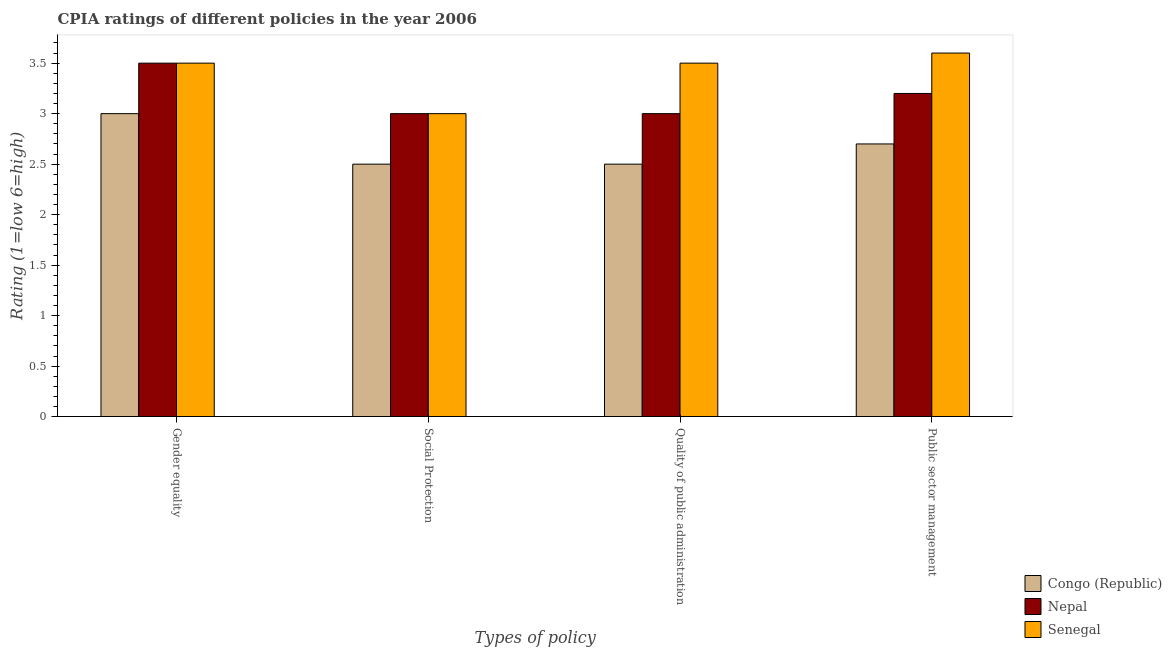How many different coloured bars are there?
Make the answer very short. 3. How many groups of bars are there?
Your response must be concise. 4. Are the number of bars per tick equal to the number of legend labels?
Make the answer very short. Yes. How many bars are there on the 4th tick from the left?
Your response must be concise. 3. What is the label of the 1st group of bars from the left?
Offer a terse response. Gender equality. Across all countries, what is the maximum cpia rating of quality of public administration?
Provide a succinct answer. 3.5. Across all countries, what is the minimum cpia rating of quality of public administration?
Your answer should be very brief. 2.5. In which country was the cpia rating of social protection maximum?
Keep it short and to the point. Nepal. In which country was the cpia rating of gender equality minimum?
Your response must be concise. Congo (Republic). What is the total cpia rating of quality of public administration in the graph?
Your answer should be compact. 9. What is the difference between the cpia rating of quality of public administration in Nepal and that in Congo (Republic)?
Give a very brief answer. 0.5. What is the average cpia rating of gender equality per country?
Give a very brief answer. 3.33. What is the difference between the cpia rating of public sector management and cpia rating of gender equality in Nepal?
Offer a terse response. -0.3. In how many countries, is the cpia rating of gender equality greater than 2.4 ?
Make the answer very short. 3. Is the cpia rating of public sector management in Senegal less than that in Nepal?
Your response must be concise. No. What is the difference between the highest and the second highest cpia rating of public sector management?
Provide a succinct answer. 0.4. Is it the case that in every country, the sum of the cpia rating of social protection and cpia rating of gender equality is greater than the sum of cpia rating of quality of public administration and cpia rating of public sector management?
Provide a succinct answer. No. What does the 2nd bar from the left in Public sector management represents?
Provide a succinct answer. Nepal. What does the 2nd bar from the right in Public sector management represents?
Provide a succinct answer. Nepal. Is it the case that in every country, the sum of the cpia rating of gender equality and cpia rating of social protection is greater than the cpia rating of quality of public administration?
Provide a succinct answer. Yes. How many bars are there?
Make the answer very short. 12. What is the difference between two consecutive major ticks on the Y-axis?
Give a very brief answer. 0.5. Are the values on the major ticks of Y-axis written in scientific E-notation?
Provide a short and direct response. No. Does the graph contain any zero values?
Your response must be concise. No. Does the graph contain grids?
Keep it short and to the point. No. How are the legend labels stacked?
Offer a terse response. Vertical. What is the title of the graph?
Offer a very short reply. CPIA ratings of different policies in the year 2006. What is the label or title of the X-axis?
Make the answer very short. Types of policy. What is the label or title of the Y-axis?
Your answer should be very brief. Rating (1=low 6=high). What is the Rating (1=low 6=high) in Congo (Republic) in Gender equality?
Your answer should be very brief. 3. What is the Rating (1=low 6=high) in Nepal in Gender equality?
Keep it short and to the point. 3.5. What is the Rating (1=low 6=high) of Senegal in Gender equality?
Your response must be concise. 3.5. What is the Rating (1=low 6=high) of Senegal in Social Protection?
Your response must be concise. 3. What is the Rating (1=low 6=high) of Congo (Republic) in Quality of public administration?
Provide a short and direct response. 2.5. What is the Rating (1=low 6=high) in Senegal in Quality of public administration?
Offer a terse response. 3.5. What is the Rating (1=low 6=high) in Congo (Republic) in Public sector management?
Your answer should be very brief. 2.7. What is the Rating (1=low 6=high) in Nepal in Public sector management?
Offer a terse response. 3.2. What is the Rating (1=low 6=high) in Senegal in Public sector management?
Give a very brief answer. 3.6. Across all Types of policy, what is the maximum Rating (1=low 6=high) in Senegal?
Keep it short and to the point. 3.6. Across all Types of policy, what is the minimum Rating (1=low 6=high) in Congo (Republic)?
Provide a succinct answer. 2.5. What is the difference between the Rating (1=low 6=high) of Congo (Republic) in Gender equality and that in Social Protection?
Your answer should be very brief. 0.5. What is the difference between the Rating (1=low 6=high) in Congo (Republic) in Gender equality and that in Quality of public administration?
Ensure brevity in your answer.  0.5. What is the difference between the Rating (1=low 6=high) of Nepal in Gender equality and that in Quality of public administration?
Provide a succinct answer. 0.5. What is the difference between the Rating (1=low 6=high) in Congo (Republic) in Gender equality and that in Public sector management?
Ensure brevity in your answer.  0.3. What is the difference between the Rating (1=low 6=high) of Senegal in Gender equality and that in Public sector management?
Your response must be concise. -0.1. What is the difference between the Rating (1=low 6=high) of Senegal in Social Protection and that in Quality of public administration?
Provide a short and direct response. -0.5. What is the difference between the Rating (1=low 6=high) in Nepal in Social Protection and that in Public sector management?
Keep it short and to the point. -0.2. What is the difference between the Rating (1=low 6=high) in Nepal in Quality of public administration and that in Public sector management?
Your answer should be very brief. -0.2. What is the difference between the Rating (1=low 6=high) in Congo (Republic) in Gender equality and the Rating (1=low 6=high) in Nepal in Social Protection?
Keep it short and to the point. 0. What is the difference between the Rating (1=low 6=high) in Congo (Republic) in Gender equality and the Rating (1=low 6=high) in Senegal in Quality of public administration?
Offer a terse response. -0.5. What is the difference between the Rating (1=low 6=high) of Nepal in Gender equality and the Rating (1=low 6=high) of Senegal in Quality of public administration?
Give a very brief answer. 0. What is the difference between the Rating (1=low 6=high) of Congo (Republic) in Gender equality and the Rating (1=low 6=high) of Nepal in Public sector management?
Offer a very short reply. -0.2. What is the difference between the Rating (1=low 6=high) of Congo (Republic) in Gender equality and the Rating (1=low 6=high) of Senegal in Public sector management?
Give a very brief answer. -0.6. What is the difference between the Rating (1=low 6=high) of Congo (Republic) in Social Protection and the Rating (1=low 6=high) of Nepal in Quality of public administration?
Keep it short and to the point. -0.5. What is the difference between the Rating (1=low 6=high) in Congo (Republic) in Social Protection and the Rating (1=low 6=high) in Senegal in Quality of public administration?
Provide a succinct answer. -1. What is the difference between the Rating (1=low 6=high) in Congo (Republic) in Social Protection and the Rating (1=low 6=high) in Nepal in Public sector management?
Offer a terse response. -0.7. What is the difference between the Rating (1=low 6=high) in Nepal in Social Protection and the Rating (1=low 6=high) in Senegal in Public sector management?
Give a very brief answer. -0.6. What is the difference between the Rating (1=low 6=high) of Congo (Republic) in Quality of public administration and the Rating (1=low 6=high) of Nepal in Public sector management?
Your answer should be compact. -0.7. What is the difference between the Rating (1=low 6=high) of Congo (Republic) in Quality of public administration and the Rating (1=low 6=high) of Senegal in Public sector management?
Make the answer very short. -1.1. What is the average Rating (1=low 6=high) of Congo (Republic) per Types of policy?
Your response must be concise. 2.67. What is the average Rating (1=low 6=high) of Nepal per Types of policy?
Offer a very short reply. 3.17. What is the average Rating (1=low 6=high) of Senegal per Types of policy?
Your response must be concise. 3.4. What is the difference between the Rating (1=low 6=high) in Congo (Republic) and Rating (1=low 6=high) in Nepal in Gender equality?
Ensure brevity in your answer.  -0.5. What is the difference between the Rating (1=low 6=high) of Congo (Republic) and Rating (1=low 6=high) of Nepal in Social Protection?
Give a very brief answer. -0.5. What is the difference between the Rating (1=low 6=high) of Congo (Republic) and Rating (1=low 6=high) of Nepal in Quality of public administration?
Offer a very short reply. -0.5. What is the difference between the Rating (1=low 6=high) in Nepal and Rating (1=low 6=high) in Senegal in Quality of public administration?
Provide a short and direct response. -0.5. What is the difference between the Rating (1=low 6=high) of Congo (Republic) and Rating (1=low 6=high) of Nepal in Public sector management?
Provide a succinct answer. -0.5. What is the difference between the Rating (1=low 6=high) of Nepal and Rating (1=low 6=high) of Senegal in Public sector management?
Offer a terse response. -0.4. What is the ratio of the Rating (1=low 6=high) in Congo (Republic) in Gender equality to that in Social Protection?
Keep it short and to the point. 1.2. What is the ratio of the Rating (1=low 6=high) in Senegal in Gender equality to that in Social Protection?
Provide a short and direct response. 1.17. What is the ratio of the Rating (1=low 6=high) of Senegal in Gender equality to that in Quality of public administration?
Ensure brevity in your answer.  1. What is the ratio of the Rating (1=low 6=high) in Congo (Republic) in Gender equality to that in Public sector management?
Ensure brevity in your answer.  1.11. What is the ratio of the Rating (1=low 6=high) of Nepal in Gender equality to that in Public sector management?
Make the answer very short. 1.09. What is the ratio of the Rating (1=low 6=high) in Senegal in Gender equality to that in Public sector management?
Your response must be concise. 0.97. What is the ratio of the Rating (1=low 6=high) in Congo (Republic) in Social Protection to that in Quality of public administration?
Your answer should be very brief. 1. What is the ratio of the Rating (1=low 6=high) of Nepal in Social Protection to that in Quality of public administration?
Make the answer very short. 1. What is the ratio of the Rating (1=low 6=high) in Senegal in Social Protection to that in Quality of public administration?
Ensure brevity in your answer.  0.86. What is the ratio of the Rating (1=low 6=high) of Congo (Republic) in Social Protection to that in Public sector management?
Your answer should be compact. 0.93. What is the ratio of the Rating (1=low 6=high) in Nepal in Social Protection to that in Public sector management?
Your answer should be compact. 0.94. What is the ratio of the Rating (1=low 6=high) of Congo (Republic) in Quality of public administration to that in Public sector management?
Provide a succinct answer. 0.93. What is the ratio of the Rating (1=low 6=high) of Nepal in Quality of public administration to that in Public sector management?
Keep it short and to the point. 0.94. What is the ratio of the Rating (1=low 6=high) of Senegal in Quality of public administration to that in Public sector management?
Provide a short and direct response. 0.97. What is the difference between the highest and the second highest Rating (1=low 6=high) in Senegal?
Keep it short and to the point. 0.1. What is the difference between the highest and the lowest Rating (1=low 6=high) in Congo (Republic)?
Your answer should be very brief. 0.5. What is the difference between the highest and the lowest Rating (1=low 6=high) in Nepal?
Provide a succinct answer. 0.5. What is the difference between the highest and the lowest Rating (1=low 6=high) of Senegal?
Give a very brief answer. 0.6. 